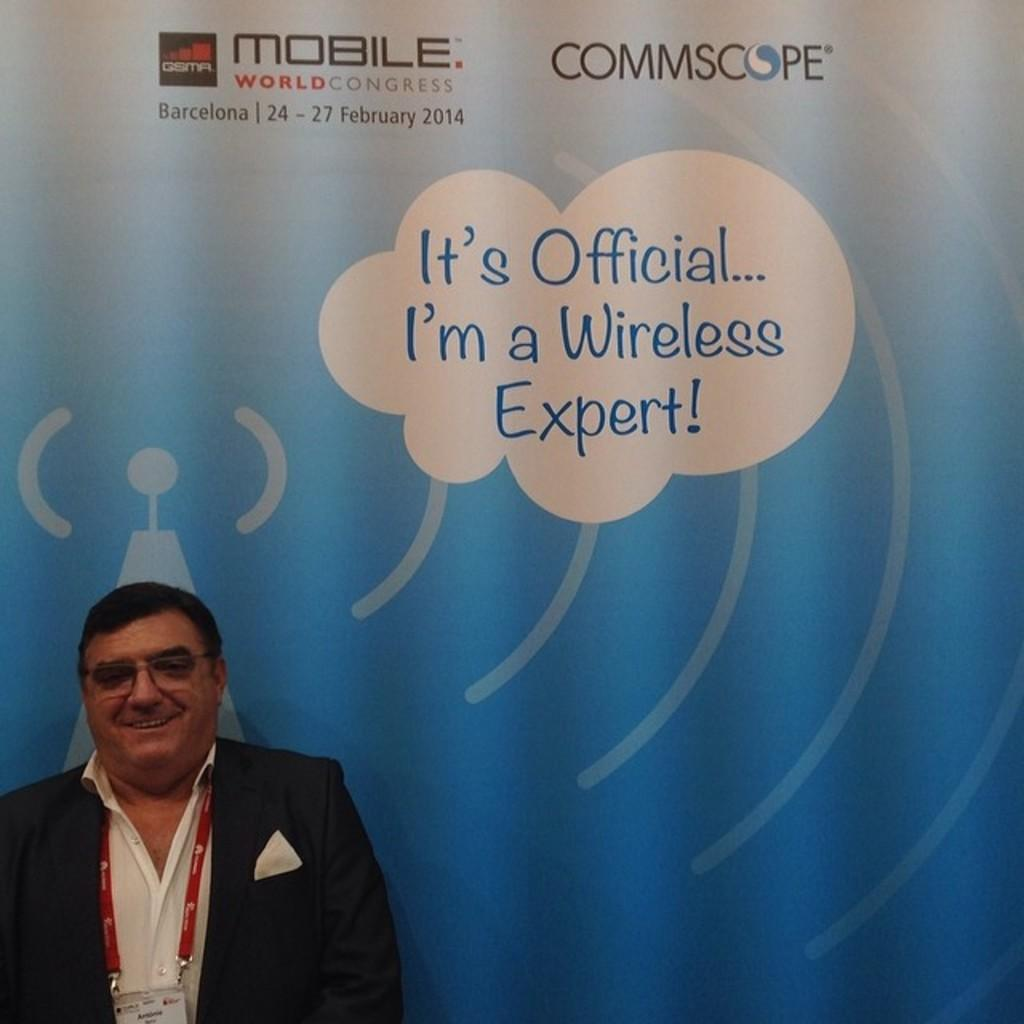<image>
Relay a brief, clear account of the picture shown. A man with a badge in front of a sign that says It's Official...I'm a Wireless Expert! 